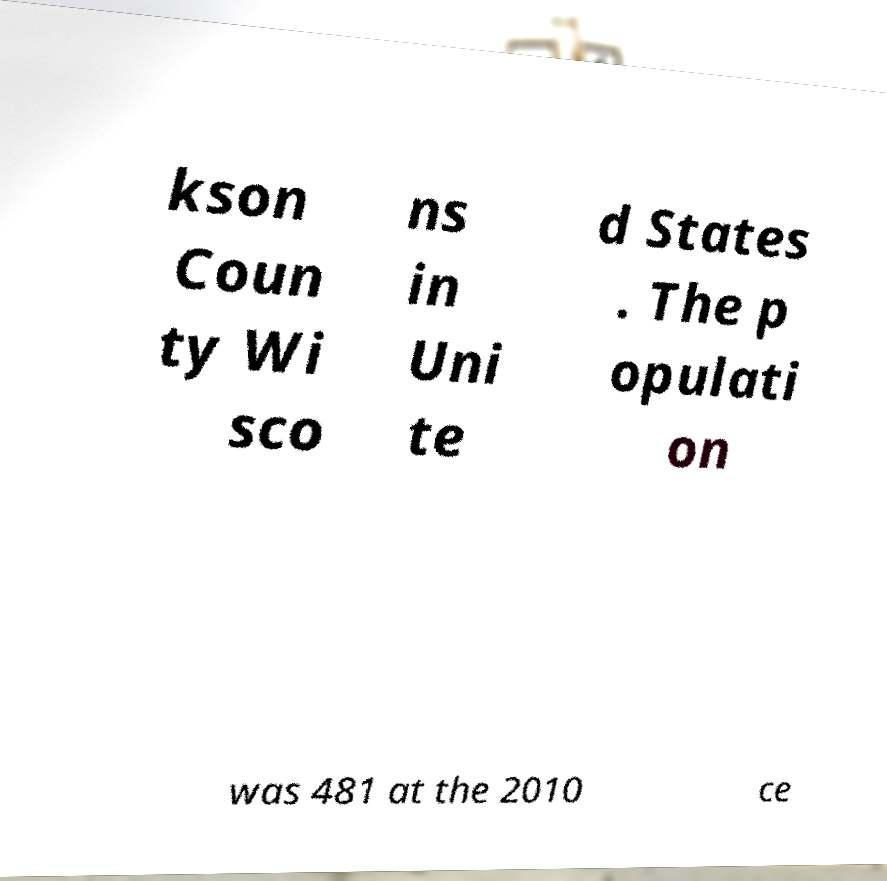Can you read and provide the text displayed in the image?This photo seems to have some interesting text. Can you extract and type it out for me? kson Coun ty Wi sco ns in Uni te d States . The p opulati on was 481 at the 2010 ce 